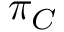Convert formula to latex. <formula><loc_0><loc_0><loc_500><loc_500>\pi _ { C }</formula> 